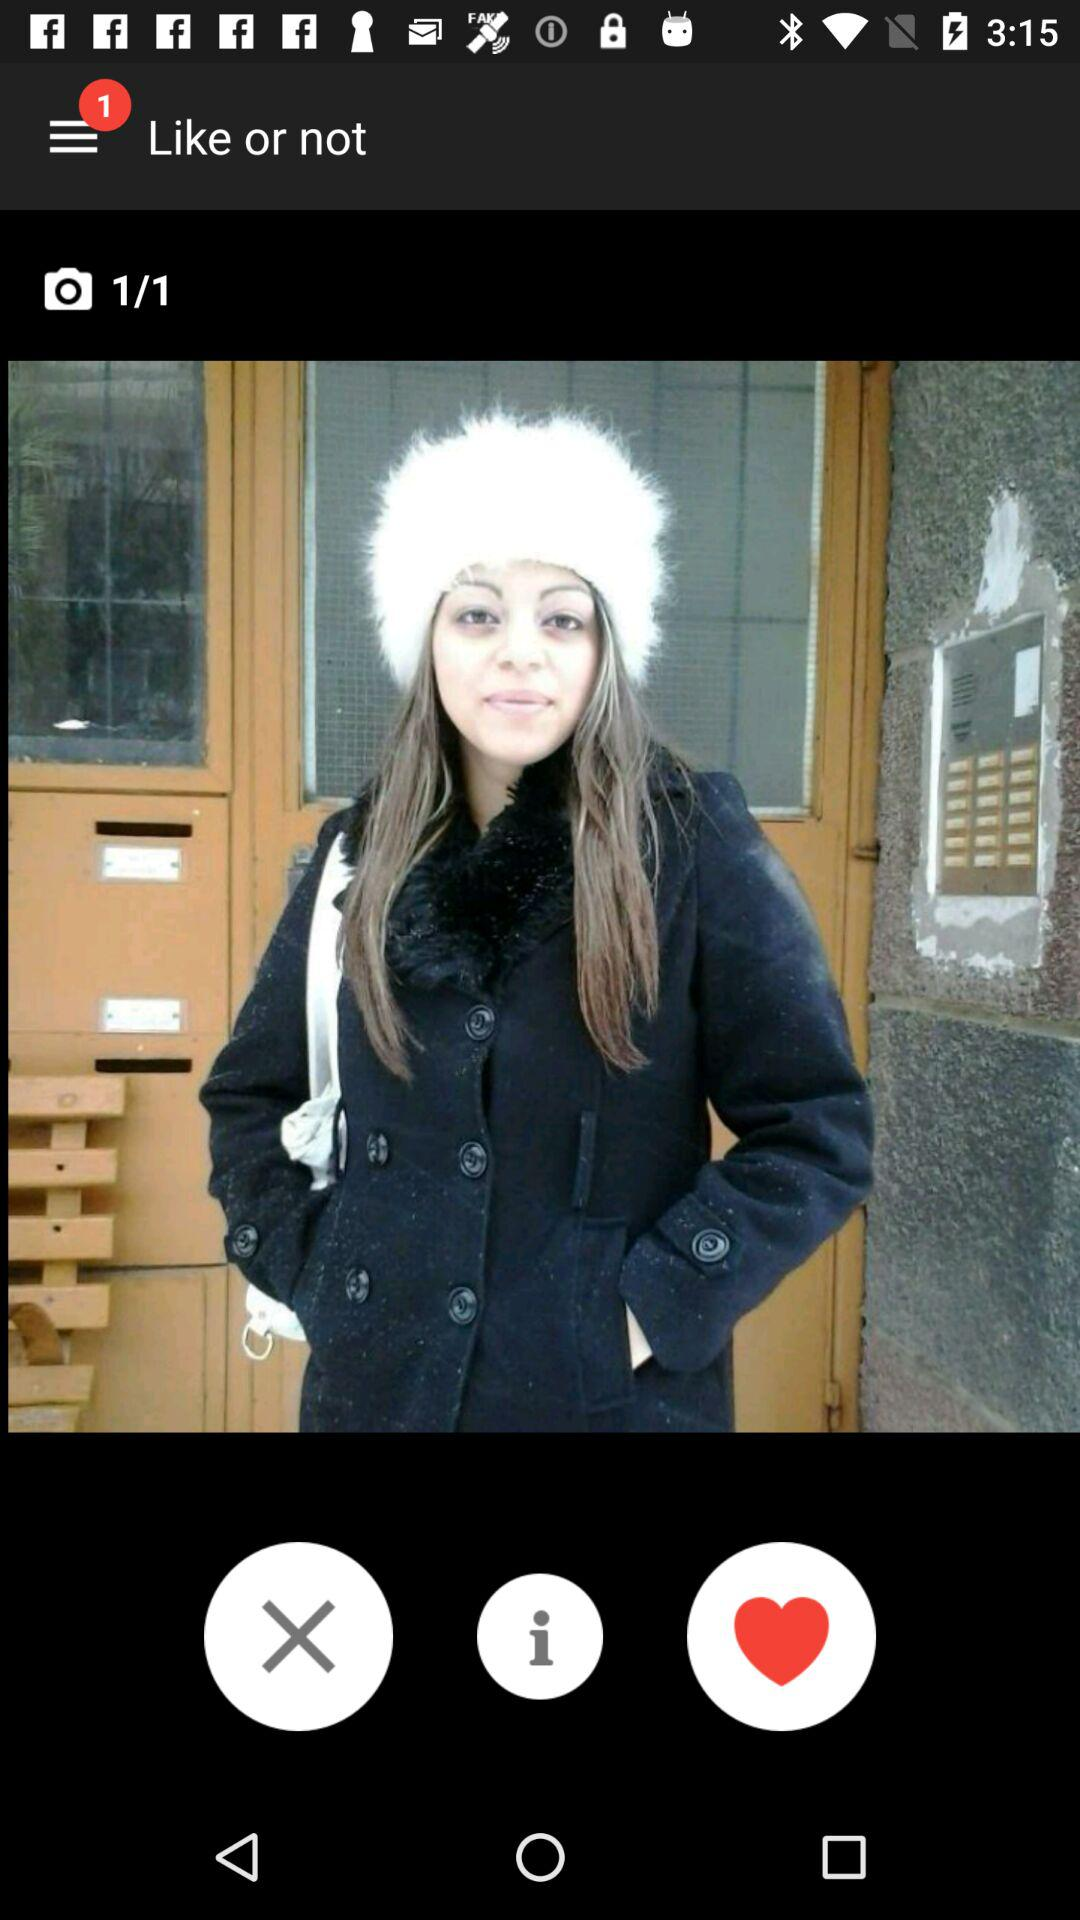Which number picture is open? The open picture number is 1. 